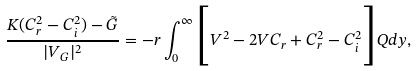<formula> <loc_0><loc_0><loc_500><loc_500>\frac { K ( C _ { r } ^ { 2 } - C _ { i } ^ { 2 } ) - \tilde { G } } { | V _ { G } | ^ { 2 } } = - r \int ^ { \infty } _ { 0 } \Big { [ } V ^ { 2 } - 2 V C _ { r } + C _ { r } ^ { 2 } - C _ { i } ^ { 2 } \Big { ] } Q d y ,</formula> 